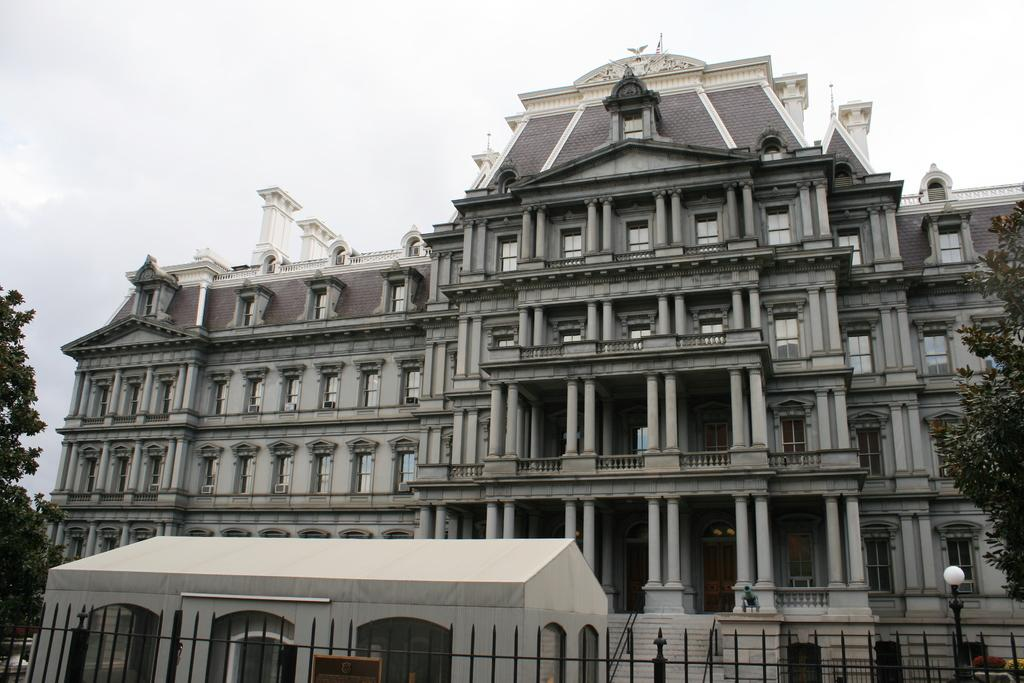What type of structures can be seen in the image? There are buildings and a shed in the image. Are there any barriers or enclosures visible in the image? Yes, there are fences in the image. What type of natural elements can be seen in the image? There are trees in the image. What is visible in the background of the image? The sky is visible in the image. What type of shoes is the scarecrow wearing in the image? There is no scarecrow present in the image, so it is not possible to determine what type of shoes it might be wearing. 